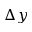Convert formula to latex. <formula><loc_0><loc_0><loc_500><loc_500>\Delta y</formula> 